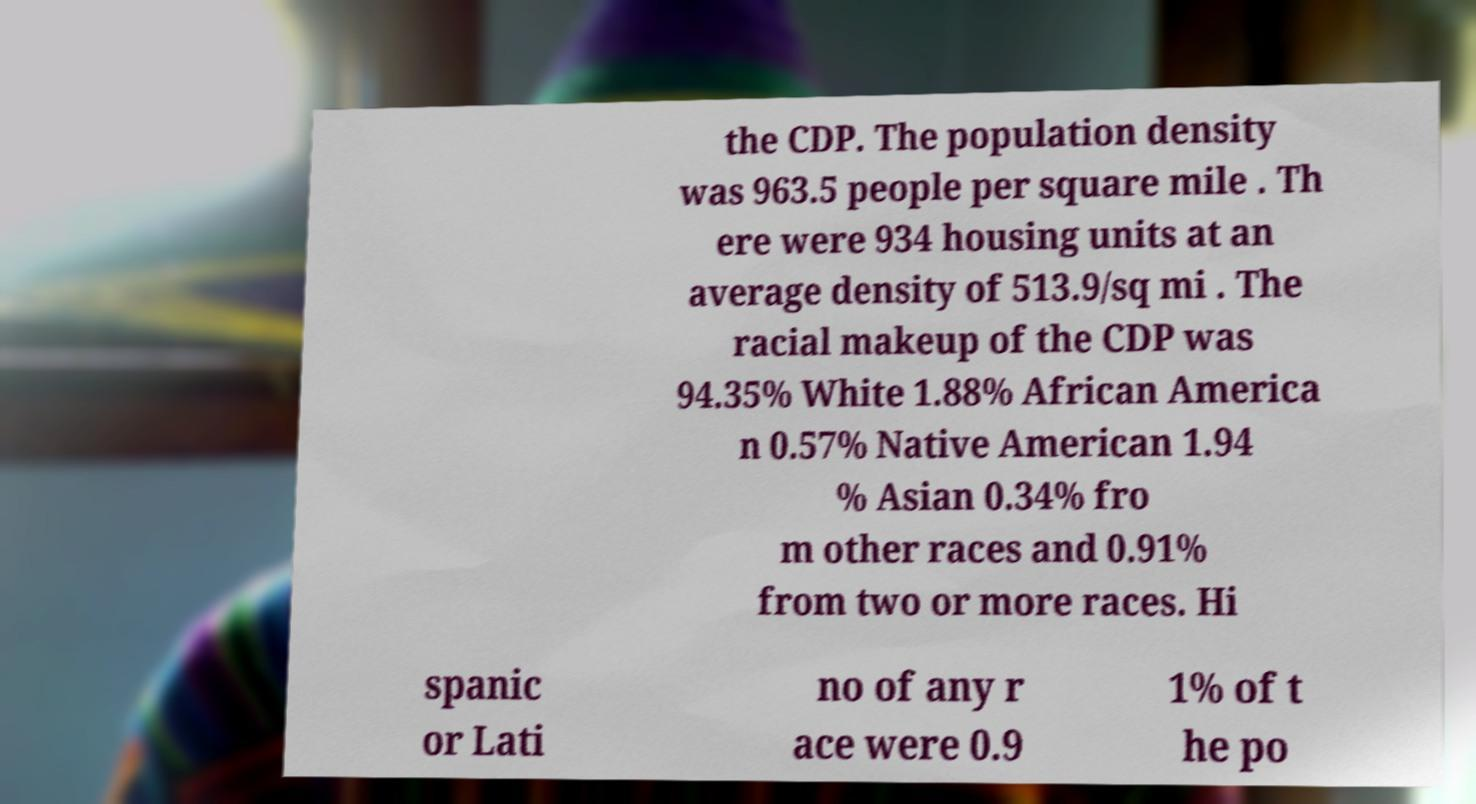Can you accurately transcribe the text from the provided image for me? the CDP. The population density was 963.5 people per square mile . Th ere were 934 housing units at an average density of 513.9/sq mi . The racial makeup of the CDP was 94.35% White 1.88% African America n 0.57% Native American 1.94 % Asian 0.34% fro m other races and 0.91% from two or more races. Hi spanic or Lati no of any r ace were 0.9 1% of t he po 